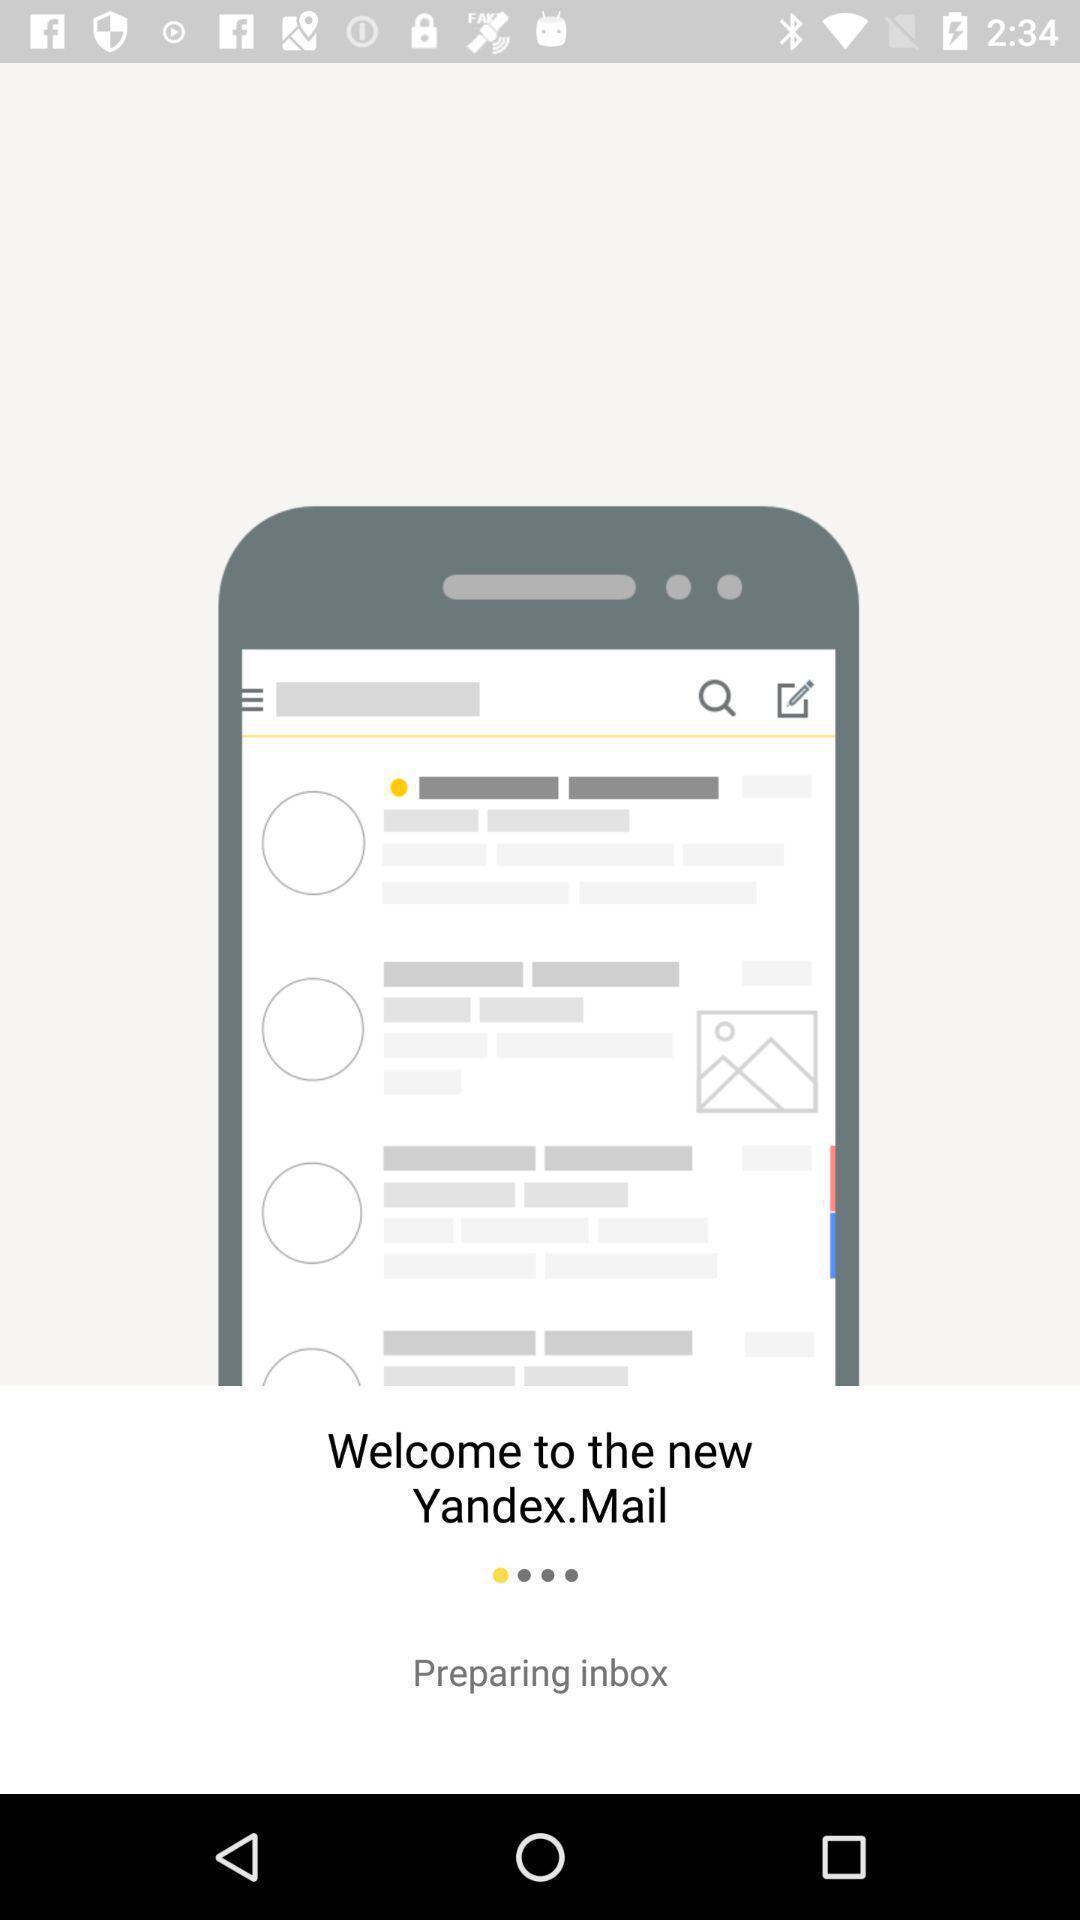Summarize the main components in this picture. Welcome page of mailing application. 